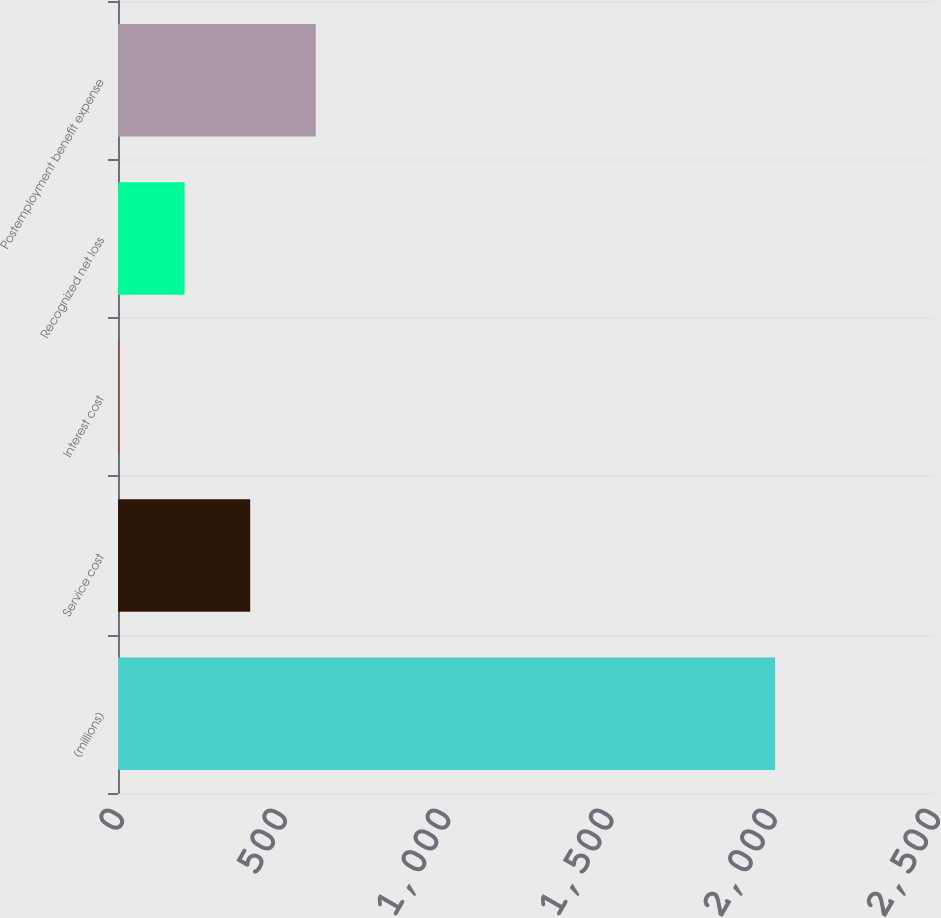Convert chart. <chart><loc_0><loc_0><loc_500><loc_500><bar_chart><fcel>(millions)<fcel>Service cost<fcel>Interest cost<fcel>Recognized net loss<fcel>Postemployment benefit expense<nl><fcel>2013<fcel>405<fcel>3<fcel>204<fcel>606<nl></chart> 